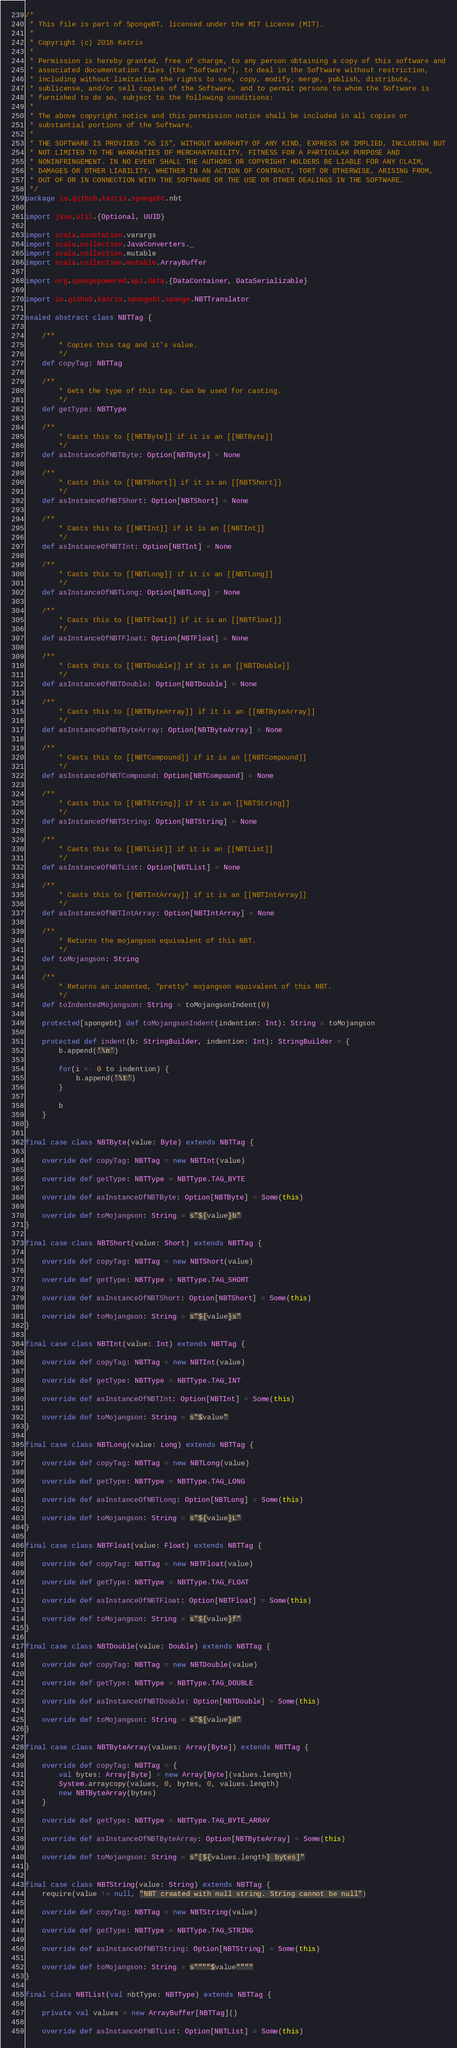<code> <loc_0><loc_0><loc_500><loc_500><_Scala_>/*
 * This file is part of SpongeBT, licensed under the MIT License (MIT).
 *
 * Copyright (c) 2016 Katrix
 *
 * Permission is hereby granted, free of charge, to any person obtaining a copy of this software and
 * associated documentation files (the "Software"), to deal in the Software without restriction,
 * including without limitation the rights to use, copy, modify, merge, publish, distribute,
 * sublicense, and/or sell copies of the Software, and to permit persons to whom the Software is
 * furnished to do so, subject to the following conditions:
 *
 * The above copyright notice and this permission notice shall be included in all copies or
 * substantial portions of the Software.
 *
 * THE SOFTWARE IS PROVIDED "AS IS", WITHOUT WARRANTY OF ANY KIND, EXPRESS OR IMPLIED, INCLUDING BUT
 * NOT LIMITED TO THE WARRANTIES OF MERCHANTABILITY, FITNESS FOR A PARTICULAR PURPOSE AND
 * NONINFRINGEMENT. IN NO EVENT SHALL THE AUTHORS OR COPYRIGHT HOLDERS BE LIABLE FOR ANY CLAIM,
 * DAMAGES OR OTHER LIABILITY, WHETHER IN AN ACTION OF CONTRACT, TORT OR OTHERWISE, ARISING FROM,
 * OUT OF OR IN CONNECTION WITH THE SOFTWARE OR THE USE OR OTHER DEALINGS IN THE SOFTWARE.
 */
package io.github.katrix.spongebt.nbt

import java.util.{Optional, UUID}

import scala.annotation.varargs
import scala.collection.JavaConverters._
import scala.collection.mutable
import scala.collection.mutable.ArrayBuffer

import org.spongepowered.api.data.{DataContainer, DataSerializable}

import io.github.katrix.spongebt.sponge.NBTTranslator

sealed abstract class NBTTag {

	/**
		* Copies this tag and it's value.
		*/
	def copyTag: NBTTag

	/**
		* Gets the type of this tag. Can be used for casting.
		*/
	def getType: NBTType

	/**
		* Casts this to [[NBTByte]] if it is an [[NBTByte]]
		*/
	def asInstanceOfNBTByte: Option[NBTByte] = None

	/**
		* Casts this to [[NBTShort]] if it is an [[NBTShort]]
		*/
	def asInstanceOfNBTShort: Option[NBTShort] = None

	/**
		* Casts this to [[NBTInt]] if it is an [[NBTInt]]
		*/
	def asInstanceOfNBTInt: Option[NBTInt] = None

	/**
		* Casts this to [[NBTLong]] if it is an [[NBTLong]]
		*/
	def asInstanceOfNBTLong: Option[NBTLong] = None

	/**
		* Casts this to [[NBTFloat]] if it is an [[NBTFloat]]
		*/
	def asInstanceOfNBTFloat: Option[NBTFloat] = None

	/**
		* Casts this to [[NBTDouble]] if it is an [[NBTDouble]]
		*/
	def asInstanceOfNBTDouble: Option[NBTDouble] = None

	/**
		* Casts this to [[NBTByteArray]] if it is an [[NBTByteArray]]
		*/
	def asInstanceOfNBTByteArray: Option[NBTByteArray] = None

	/**
		* Casts this to [[NBTCompound]] if it is an [[NBTCompound]]
		*/
	def asInstanceOfNBTCompound: Option[NBTCompound] = None

	/**
		* Casts this to [[NBTString]] if it is an [[NBTString]]
		*/
	def asInstanceOfNBTString: Option[NBTString] = None

	/**
		* Casts this to [[NBTList]] if it is an [[NBTList]]
		*/
	def asInstanceOfNBTList: Option[NBTList] = None

	/**
		* Casts this to [[NBTIntArray]] if it is an [[NBTIntArray]]
		*/
	def asInstanceOfNBTIntArray: Option[NBTIntArray] = None

	/**
		* Returns the mojangson equivalent of this NBT.
		*/
	def toMojangson: String

	/**
		* Returns an indented, "pretty" mojangson equivalent of this NBT.
		*/
	def toIndentedMojangson: String = toMojangsonIndent(0)

	protected[spongebt] def toMojangsonIndent(indention: Int): String = toMojangson

	protected def indent(b: StringBuilder, indention: Int): StringBuilder = {
		b.append('\n')

		for(i <- 0 to indention) {
			b.append('\t')
		}

		b
	}
}

final case class NBTByte(value: Byte) extends NBTTag {

	override def copyTag: NBTTag = new NBTInt(value)

	override def getType: NBTType = NBTType.TAG_BYTE

	override def asInstanceOfNBTByte: Option[NBTByte] = Some(this)

	override def toMojangson: String = s"${value}b"
}

final case class NBTShort(value: Short) extends NBTTag {

	override def copyTag: NBTTag = new NBTShort(value)

	override def getType: NBTType = NBTType.TAG_SHORT

	override def asInstanceOfNBTShort: Option[NBTShort] = Some(this)

	override def toMojangson: String = s"${value}s"
}

final case class NBTInt(value: Int) extends NBTTag {

	override def copyTag: NBTTag = new NBTInt(value)

	override def getType: NBTType = NBTType.TAG_INT

	override def asInstanceOfNBTInt: Option[NBTInt] = Some(this)

	override def toMojangson: String = s"$value"
}

final case class NBTLong(value: Long) extends NBTTag {

	override def copyTag: NBTTag = new NBTLong(value)

	override def getType: NBTType = NBTType.TAG_LONG

	override def asInstanceOfNBTLong: Option[NBTLong] = Some(this)

	override def toMojangson: String = s"${value}L"
}

final case class NBTFloat(value: Float) extends NBTTag {

	override def copyTag: NBTTag = new NBTFloat(value)

	override def getType: NBTType = NBTType.TAG_FLOAT

	override def asInstanceOfNBTFloat: Option[NBTFloat] = Some(this)

	override def toMojangson: String = s"${value}f"
}

final case class NBTDouble(value: Double) extends NBTTag {

	override def copyTag: NBTTag = new NBTDouble(value)

	override def getType: NBTType = NBTType.TAG_DOUBLE

	override def asInstanceOfNBTDouble: Option[NBTDouble] = Some(this)

	override def toMojangson: String = s"${value}d"
}

final case class NBTByteArray(values: Array[Byte]) extends NBTTag {

	override def copyTag: NBTTag = {
		val bytes: Array[Byte] = new Array[Byte](values.length)
		System.arraycopy(values, 0, bytes, 0, values.length)
		new NBTByteArray(bytes)
	}

	override def getType: NBTType = NBTType.TAG_BYTE_ARRAY

	override def asInstanceOfNBTByteArray: Option[NBTByteArray] = Some(this)

	override def toMojangson: String = s"[${values.length} bytes]"
}

final case class NBTString(value: String) extends NBTTag {
	require(value != null, "NBT created with null string. String cannot be null")

	override def copyTag: NBTTag = new NBTString(value)

	override def getType: NBTType = NBTType.TAG_STRING

	override def asInstanceOfNBTString: Option[NBTString] = Some(this)

	override def toMojangson: String = s""""$value""""
}

final class NBTList(val nbtType: NBTType) extends NBTTag {

	private val values = new ArrayBuffer[NBTTag]()

	override def asInstanceOfNBTList: Option[NBTList] = Some(this)
</code> 